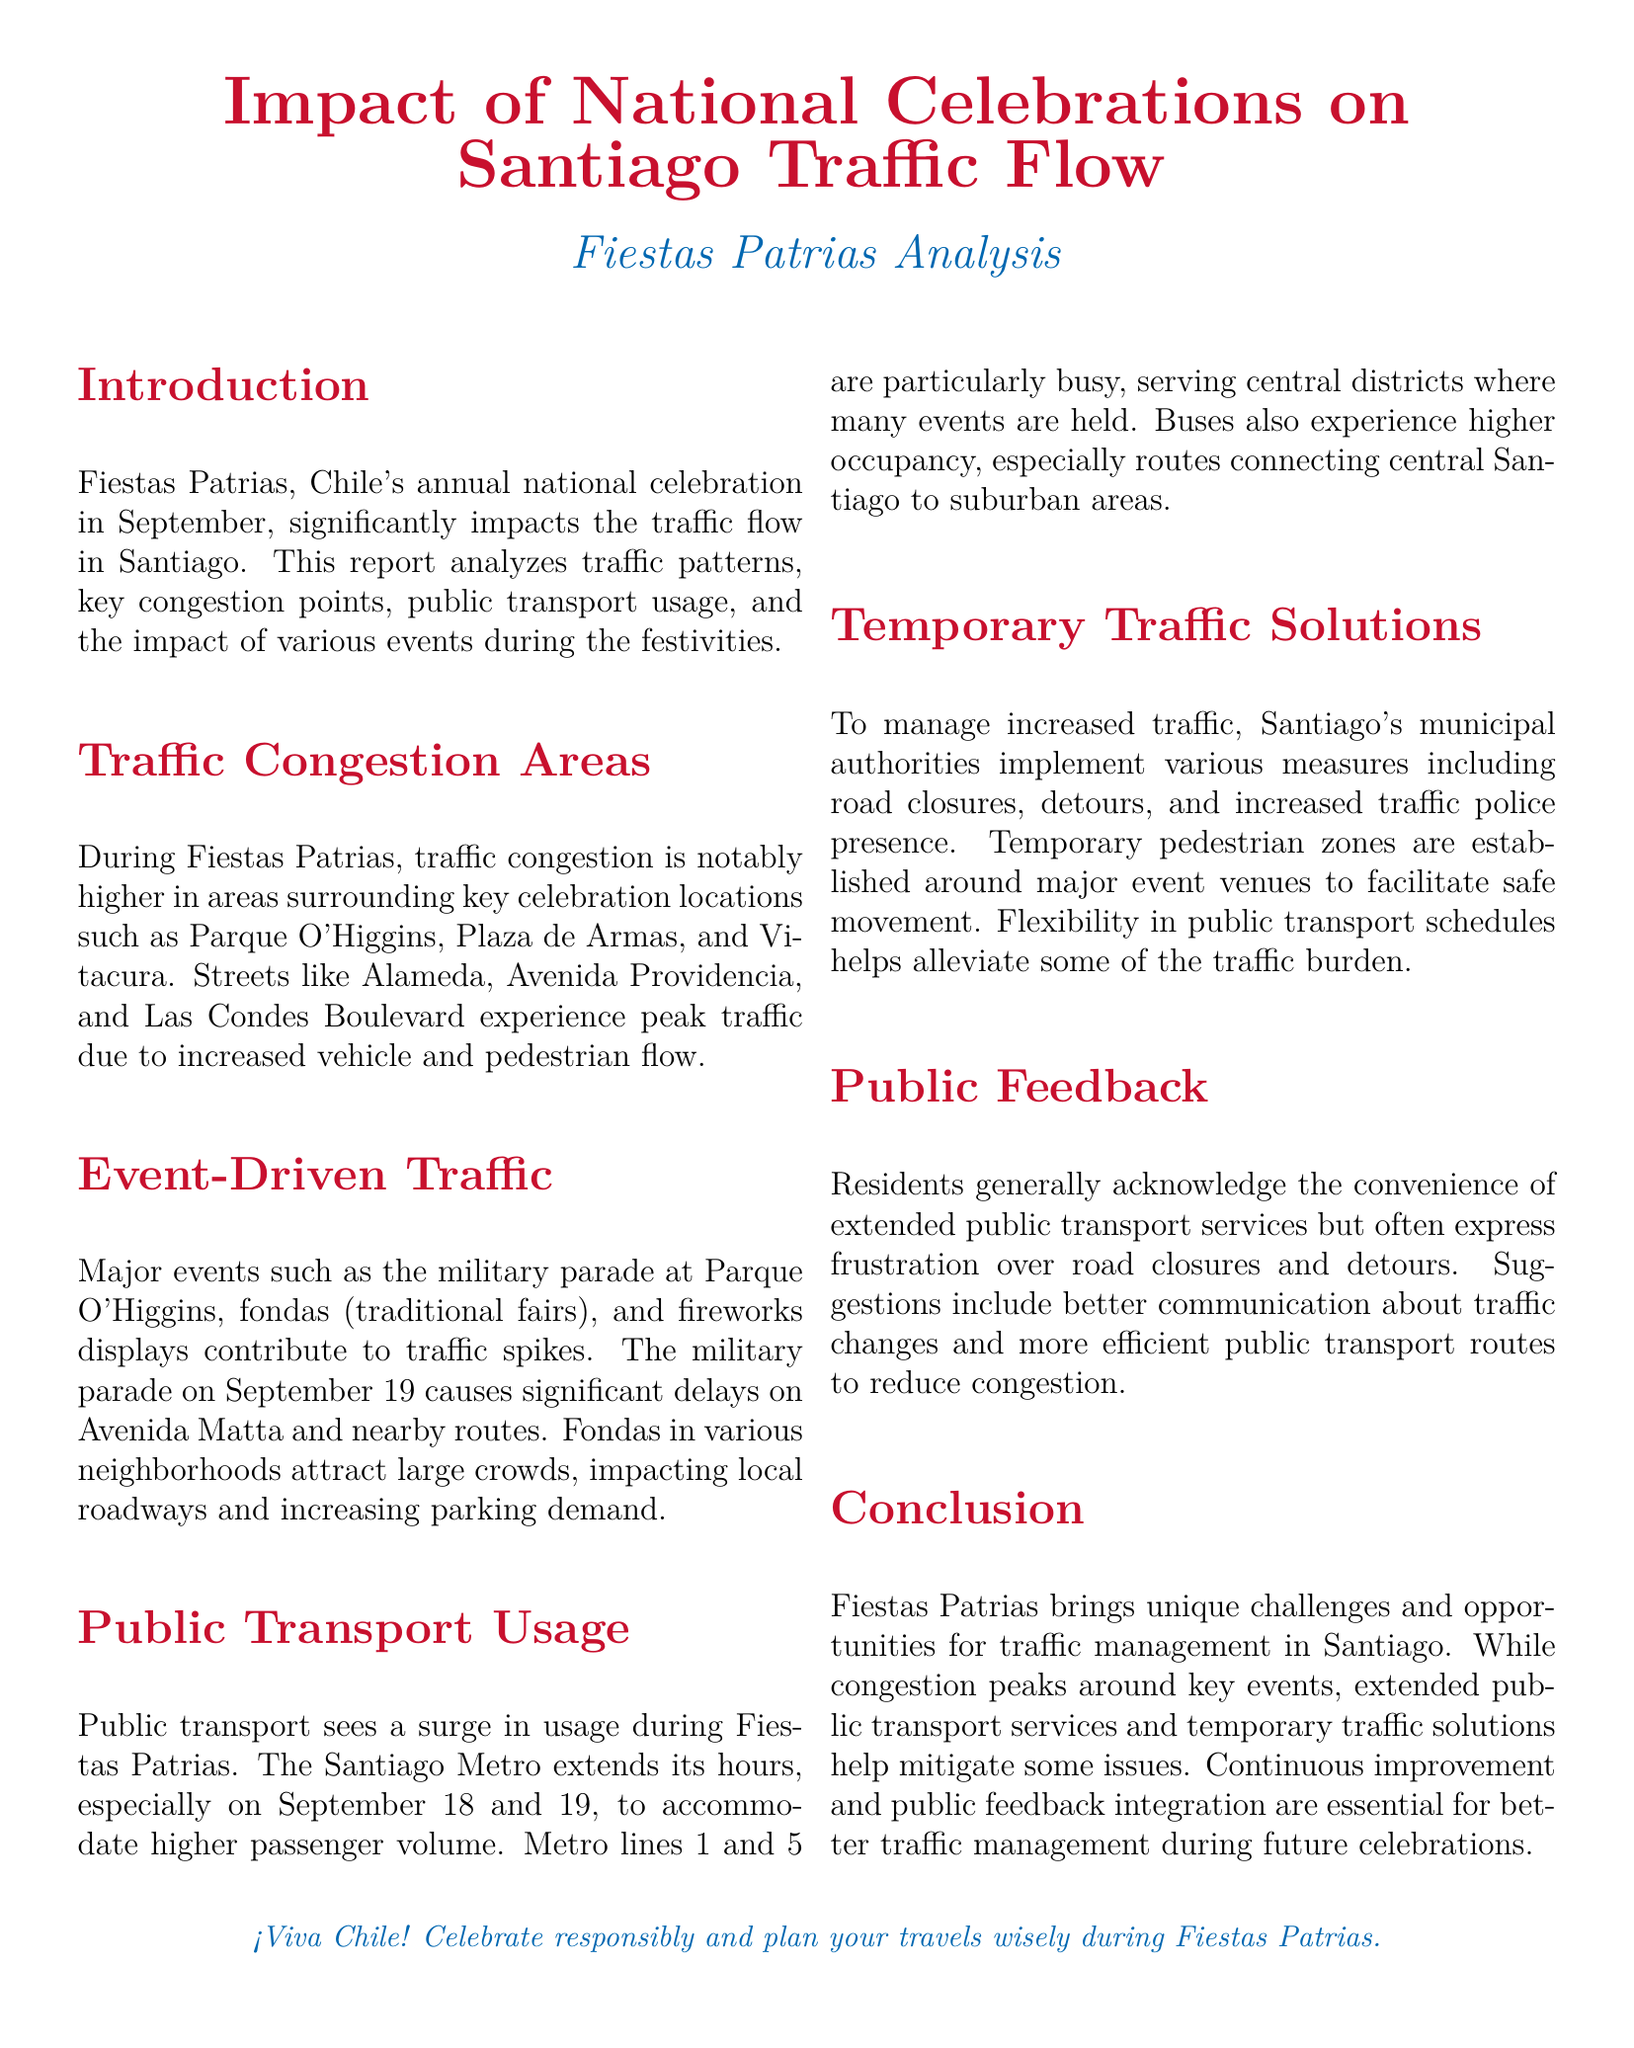What is the main focus of the report? The report focuses on how national celebrations affect traffic flow in Santiago during Fiestas Patrias.
Answer: Traffic flow Which streets experience peak traffic? The document lists specific streets that face congestion during the celebrations, such as Alameda, Avenida Providencia, and Las Condes Boulevard.
Answer: Alameda, Avenida Providencia, Las Condes Boulevard On which date does the military parade occur? The text specifies that the military parade takes place on September 19, contributing to traffic delays.
Answer: September 19 What public transport service is mentioned as extending its hours? The report highlights the Santiago Metro as a key public transport service that extends its hours during the festivities.
Answer: Santiago Metro What are temporary measures taken to manage traffic? The document outlines several measures including road closures, detours, and increased traffic police presence as ways to manage traffic.
Answer: Road closures, detours, increased traffic police Why do residents express frustration during Fiestas Patrias? The residents' feedback indicates their frustration is primarily due to road closures and detours during the celebrations.
Answer: Road closures and detours What improvement suggestion do residents have regarding public transport? The residents suggest better communication about traffic changes as a way to improve public transport efficiency during the festivities.
Answer: Better communication about traffic changes Which Metro lines are particularly busy during Fiestas Patrias? The report specifies that Metro lines 1 and 5 are particularly busy, serving central districts where events occur.
Answer: Lines 1 and 5 What is the concluding note regarding future traffic management? The conclusion states that continuous improvement and public feedback integration are essential for future traffic management during celebrations.
Answer: Continuous improvement and public feedback integration 